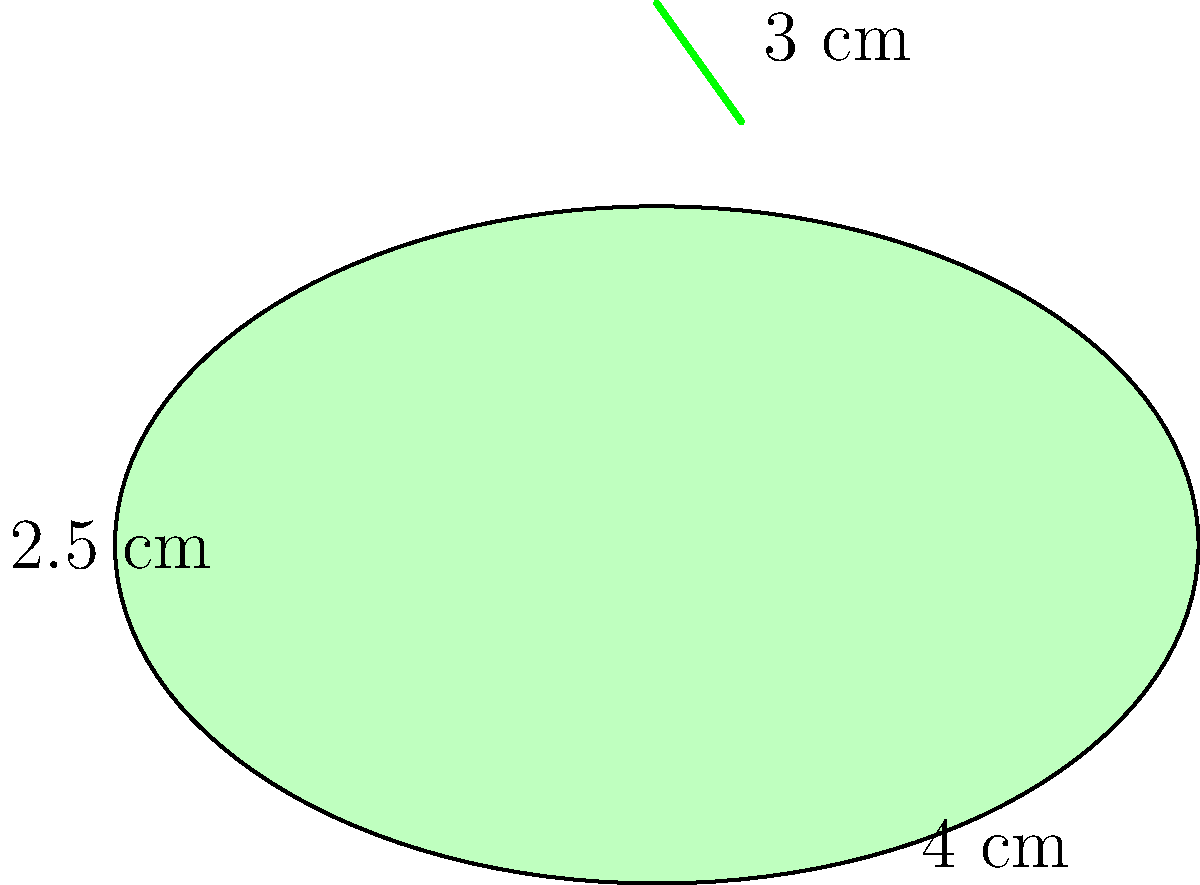As a produce stocker, you need to estimate the volume of an eggplant for inventory purposes. The eggplant can be approximated as an ellipsoid with a small cylindrical stem. If the eggplant's body measures 4 cm in width, 2.5 cm in height, and 4 cm in depth (not shown in the 2D diagram), and the stem is 3 cm long with a diameter of 0.5 cm, what is the total estimated volume of the eggplant in cubic centimeters (cm³)? Round your answer to the nearest whole number. To estimate the volume of the eggplant, we'll calculate the volumes of the ellipsoid body and cylindrical stem separately, then add them together.

1. Volume of the ellipsoid body:
   The formula for the volume of an ellipsoid is $V = \frac{4}{3}\pi abc$, where $a$, $b$, and $c$ are the semi-axes.
   
   $a = 4/2 = 2$ cm
   $b = 2.5/2 = 1.25$ cm
   $c = 4/2 = 2$ cm (depth)
   
   $V_{ellipsoid} = \frac{4}{3}\pi(2)(1.25)(2) = \frac{20}{3}\pi \approx 20.94$ cm³

2. Volume of the cylindrical stem:
   The formula for the volume of a cylinder is $V = \pi r^2 h$, where $r$ is the radius and $h$ is the height.
   
   $r = 0.5/2 = 0.25$ cm
   $h = 3$ cm
   
   $V_{cylinder} = \pi(0.25)^2(3) = \frac{3\pi}{16} \approx 0.59$ cm³

3. Total volume:
   $V_{total} = V_{ellipsoid} + V_{cylinder}$
   $V_{total} = 20.94 + 0.59 = 21.53$ cm³

4. Rounding to the nearest whole number:
   21.53 cm³ rounds to 22 cm³
Answer: 22 cm³ 